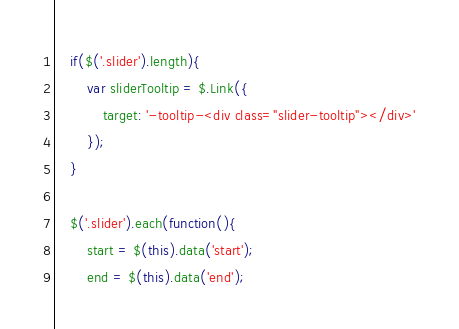Convert code to text. <code><loc_0><loc_0><loc_500><loc_500><_JavaScript_>
	if($('.slider').length){
		var sliderTooltip = $.Link({
			target: '-tooltip-<div class="slider-tooltip"></div>'
		});
	}

	$('.slider').each(function(){
		start = $(this).data('start');
		end = $(this).data('end');</code> 